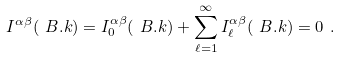Convert formula to latex. <formula><loc_0><loc_0><loc_500><loc_500>I ^ { \alpha \beta } ( \ B . k ) = I ^ { \alpha \beta } _ { 0 } ( \ B . k ) + \sum _ { \ell = 1 } ^ { \infty } I ^ { \alpha \beta } _ { \ell } ( \ B . k ) = 0 \ .</formula> 